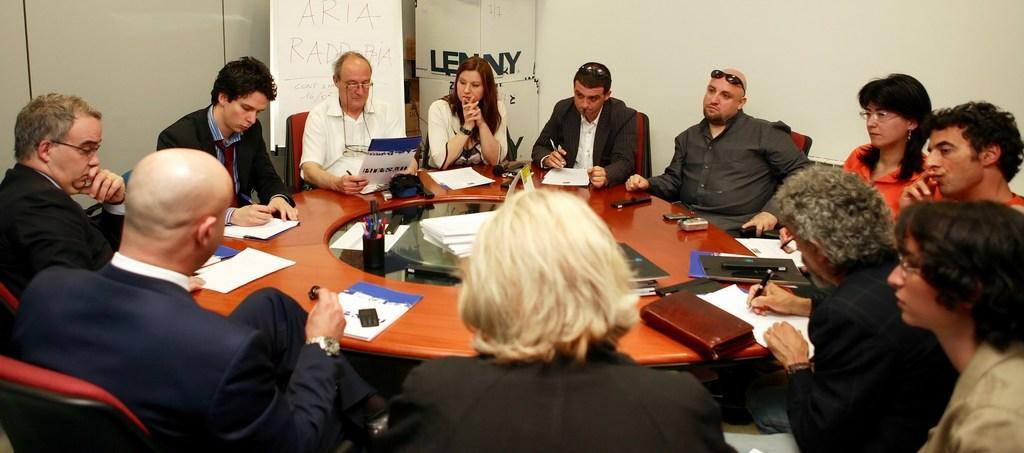How would you summarize this image in a sentence or two? In this image we can see persons sitting around the table. On the table there are mobile phones, books, pens, papers, remote and some covers. In the background there is a wall and some containers. 